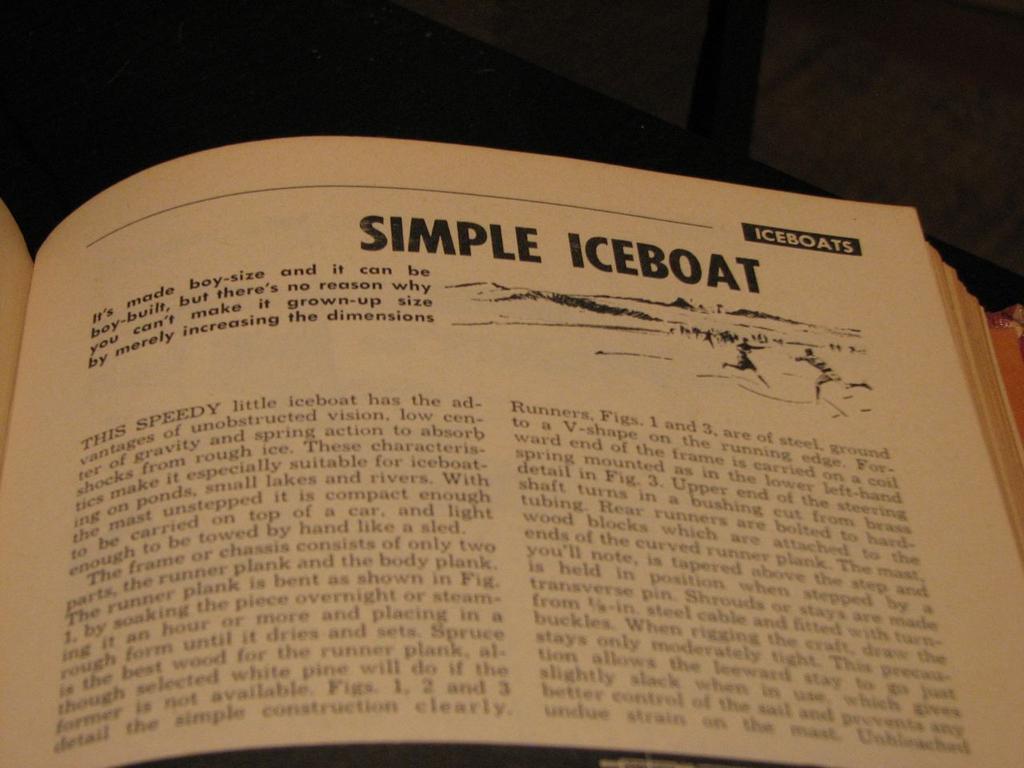What kind of boat is mentioned on the page?
Make the answer very short. Iceboat. 